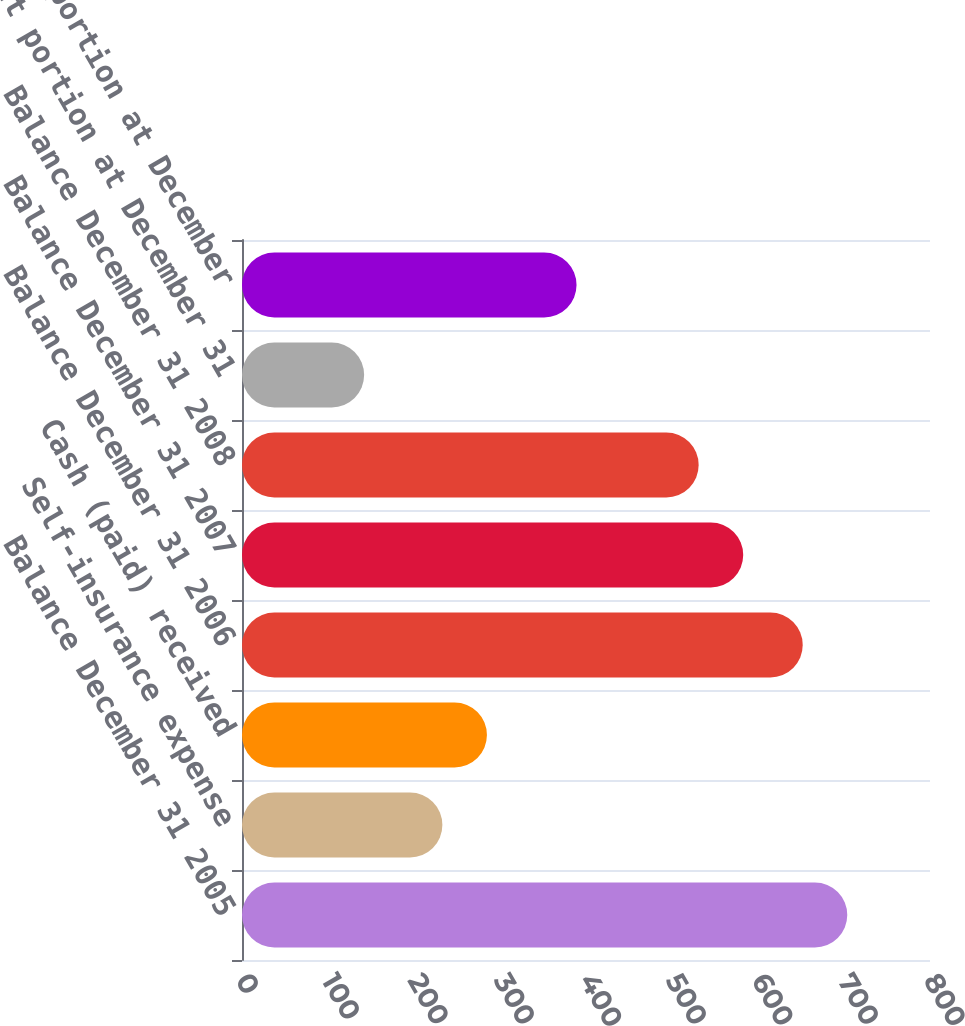Convert chart to OTSL. <chart><loc_0><loc_0><loc_500><loc_500><bar_chart><fcel>Balance December 31 2005<fcel>Self-insurance expense<fcel>Cash (paid) received<fcel>Balance December 31 2006<fcel>Balance December 31 2007<fcel>Balance December 31 2008<fcel>Current portion at December 31<fcel>Long-term portion at December<nl><fcel>703.8<fcel>233<fcel>284.8<fcel>652<fcel>582.8<fcel>531<fcel>142<fcel>389<nl></chart> 